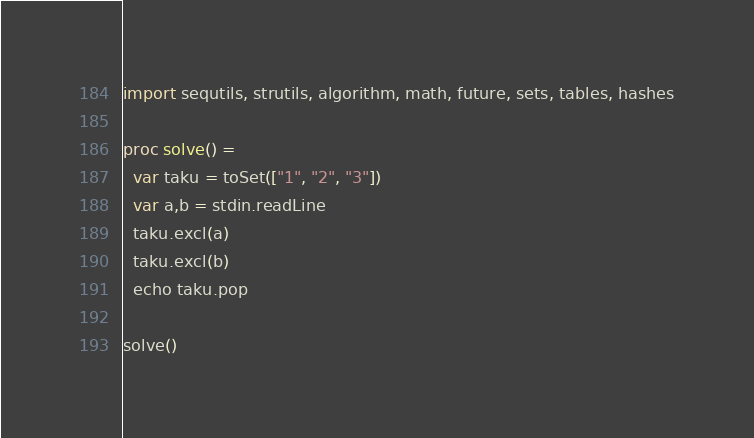Convert code to text. <code><loc_0><loc_0><loc_500><loc_500><_Nim_>import sequtils, strutils, algorithm, math, future, sets, tables, hashes

proc solve() =
  var taku = toSet(["1", "2", "3"])
  var a,b = stdin.readLine
  taku.excl(a)
  taku.excl(b)
  echo taku.pop

solve()</code> 